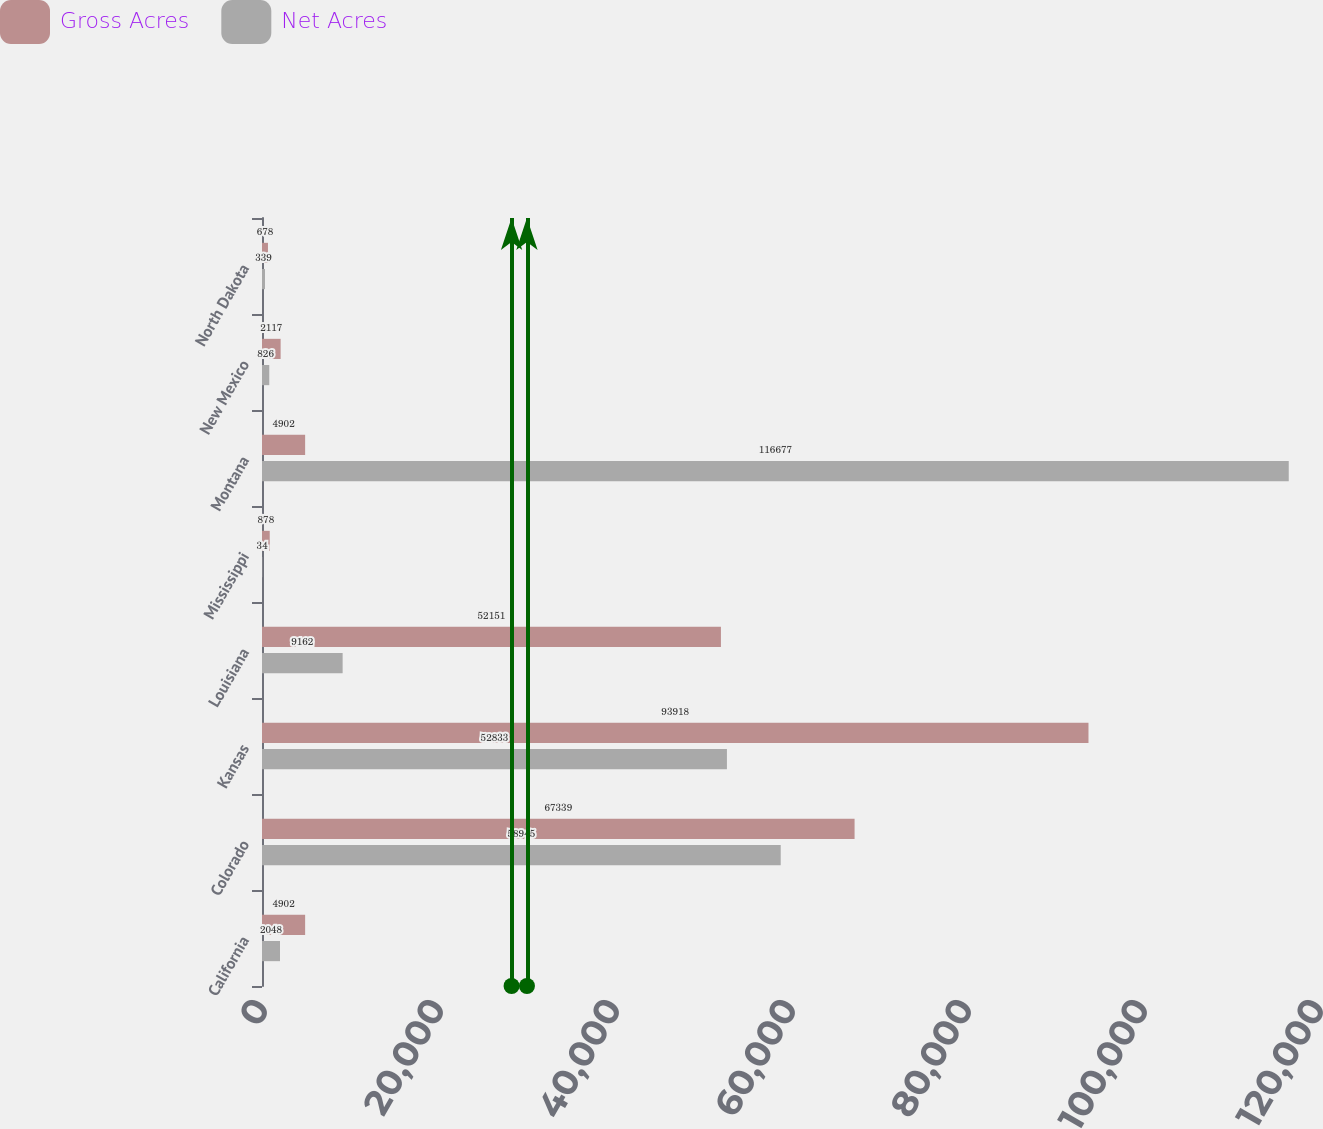Convert chart to OTSL. <chart><loc_0><loc_0><loc_500><loc_500><stacked_bar_chart><ecel><fcel>California<fcel>Colorado<fcel>Kansas<fcel>Louisiana<fcel>Mississippi<fcel>Montana<fcel>New Mexico<fcel>North Dakota<nl><fcel>Gross Acres<fcel>4902<fcel>67339<fcel>93918<fcel>52151<fcel>878<fcel>4902<fcel>2117<fcel>678<nl><fcel>Net Acres<fcel>2048<fcel>58945<fcel>52833<fcel>9162<fcel>34<fcel>116677<fcel>826<fcel>339<nl></chart> 